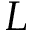Convert formula to latex. <formula><loc_0><loc_0><loc_500><loc_500>L</formula> 